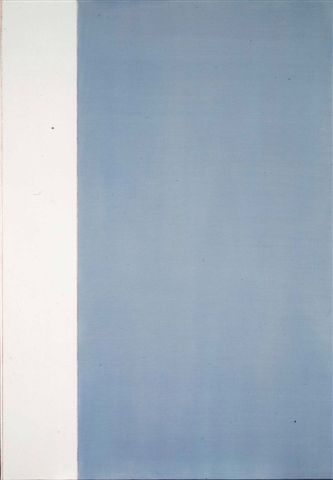Suppose this artwork had a voice. What would it say? If this artwork had a voice, it might whisper of balance and tranquility. It could say, 'In simplicity, find peace; in contrasts, see harmony. Let your gaze wander from one hue to another, and let the gradient guide you into contemplation. Embrace the quiet moments and the transitions they bring. Just as the colors blend and change, allow yourself to flow with the rhythms of life, finding calm in the journey between beginnings and depths.' 